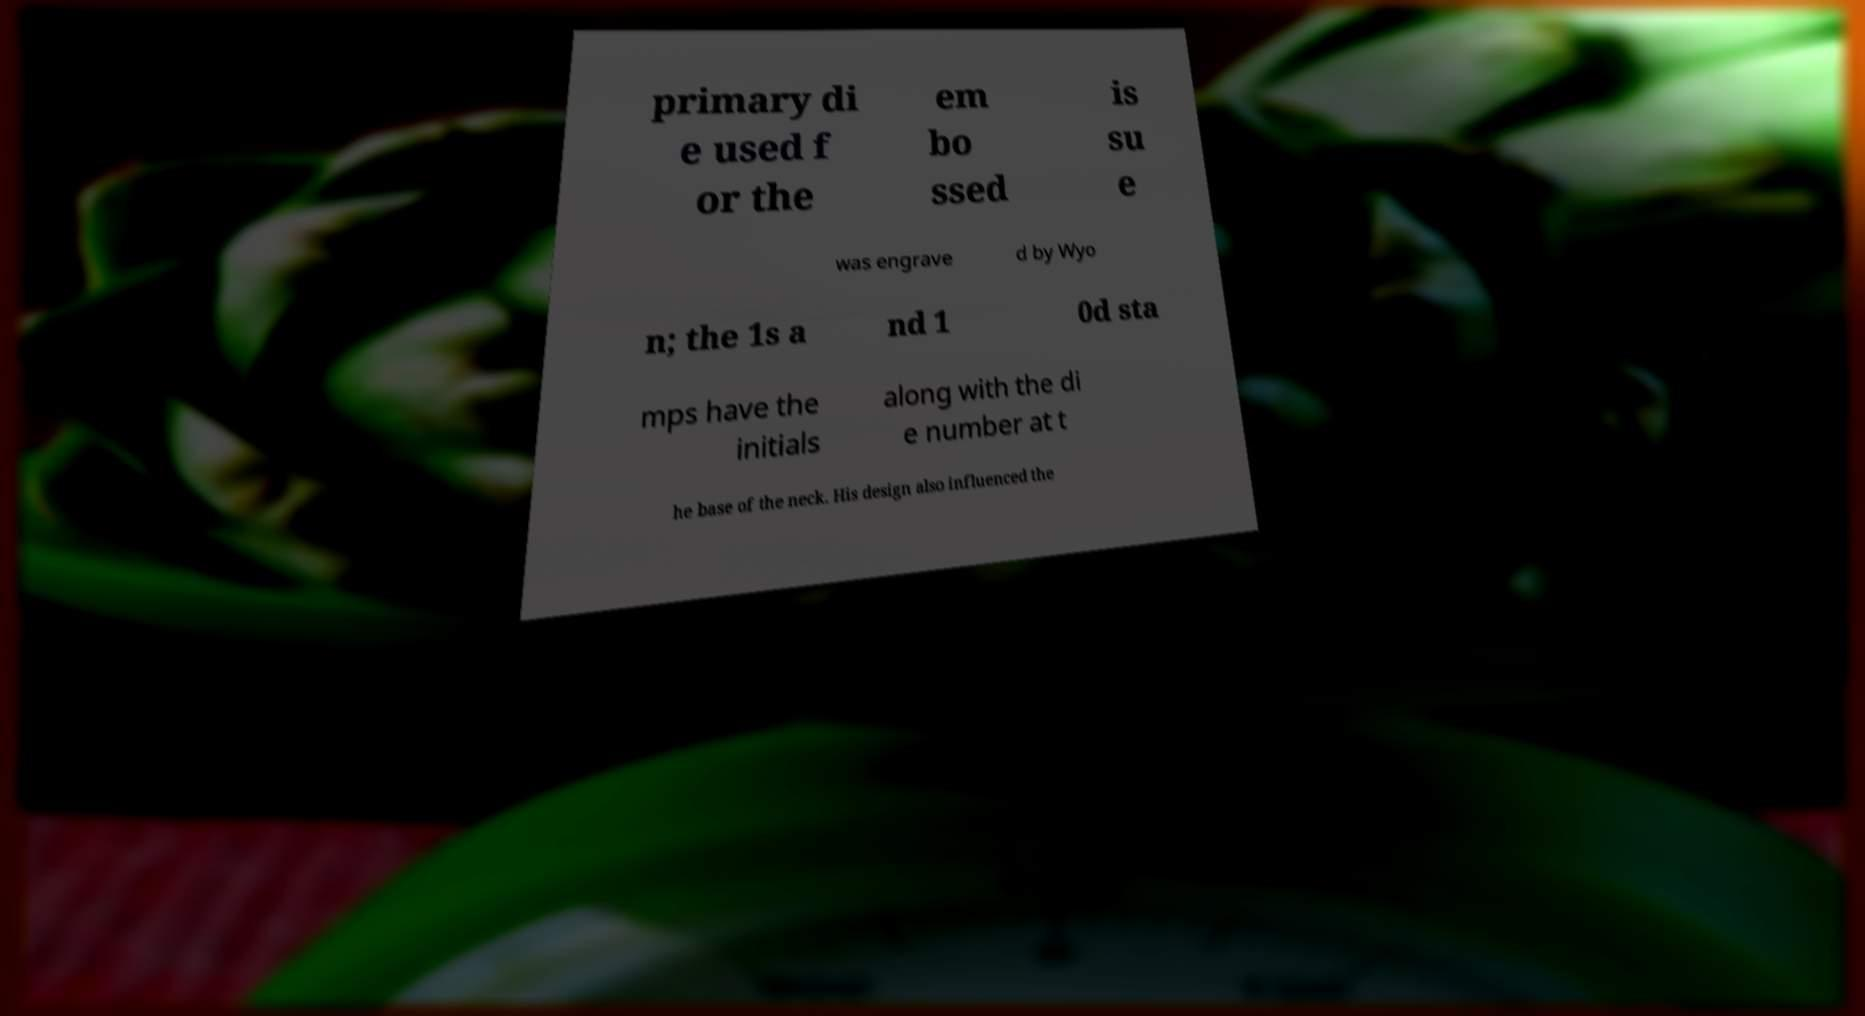Please identify and transcribe the text found in this image. primary di e used f or the em bo ssed is su e was engrave d by Wyo n; the 1s a nd 1 0d sta mps have the initials along with the di e number at t he base of the neck. His design also influenced the 